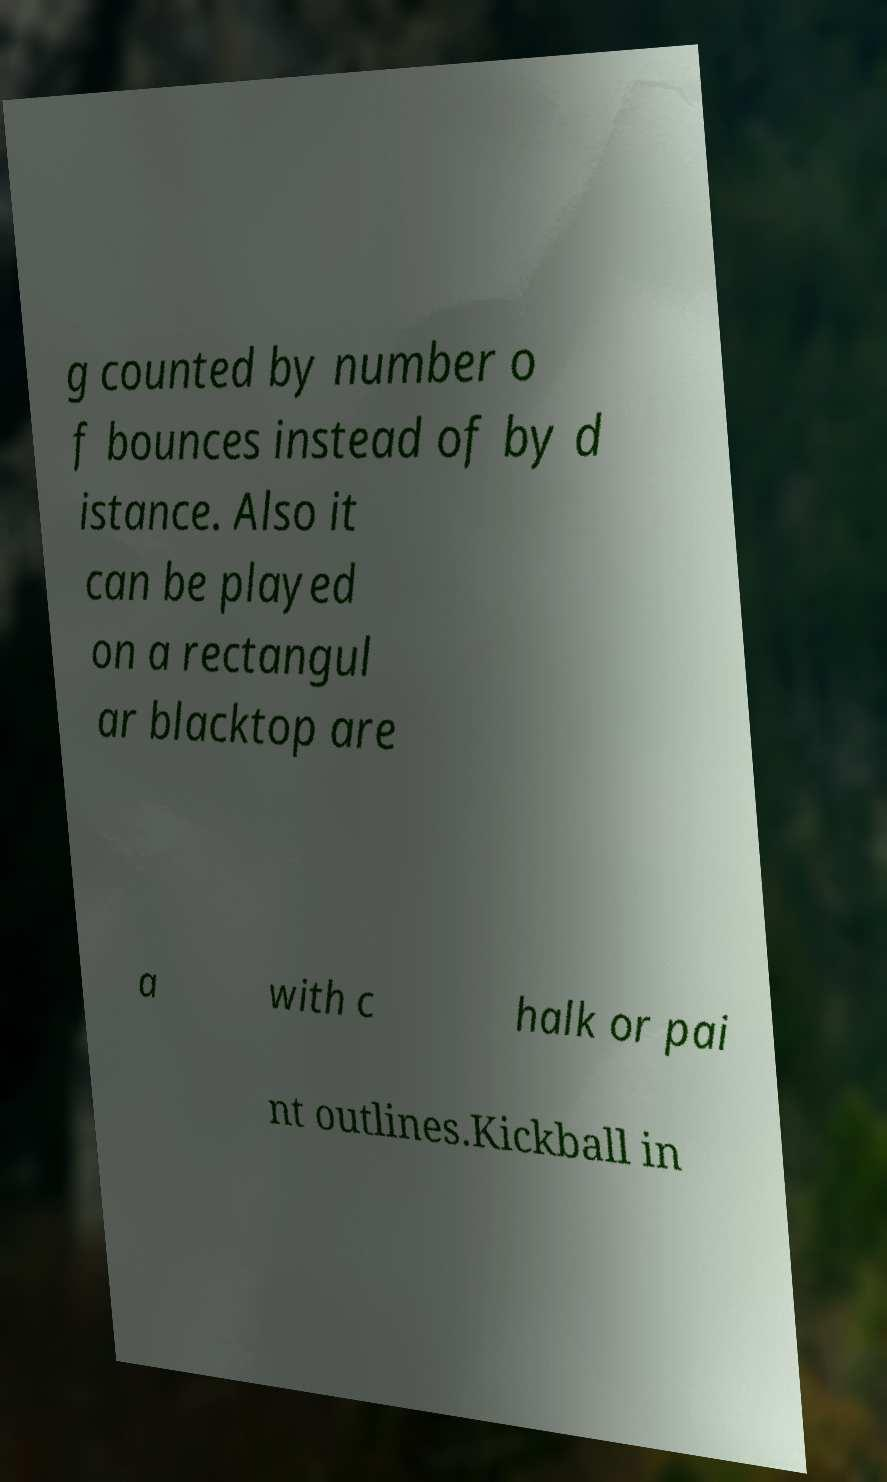I need the written content from this picture converted into text. Can you do that? g counted by number o f bounces instead of by d istance. Also it can be played on a rectangul ar blacktop are a with c halk or pai nt outlines.Kickball in 